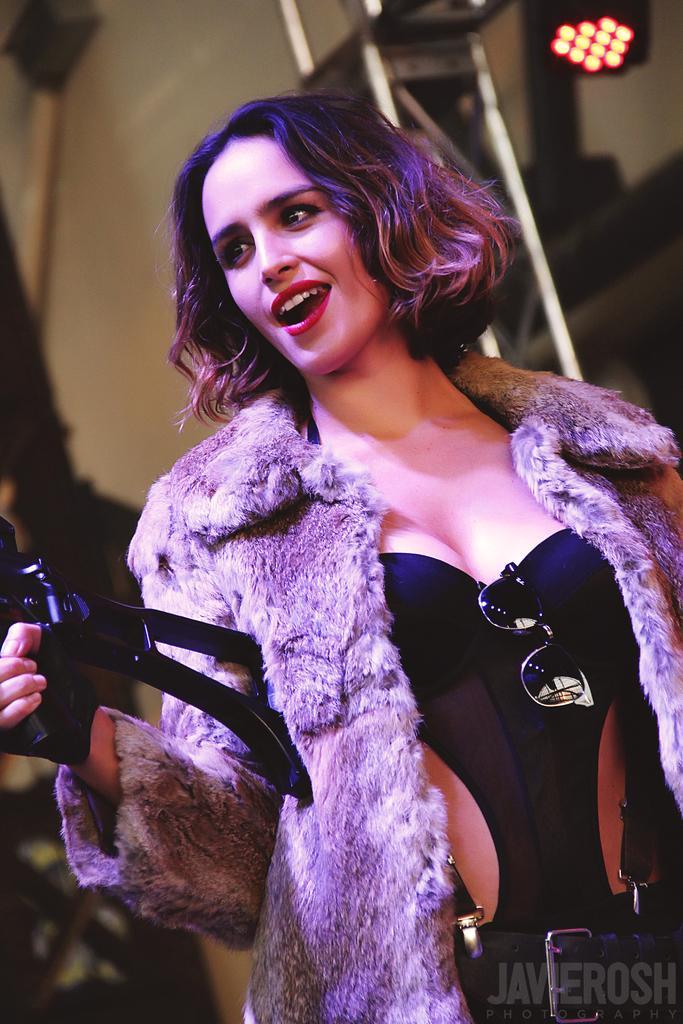Please provide a concise description of this image. In this image I can see a girl standing and holding some object, behind her there is a building. 